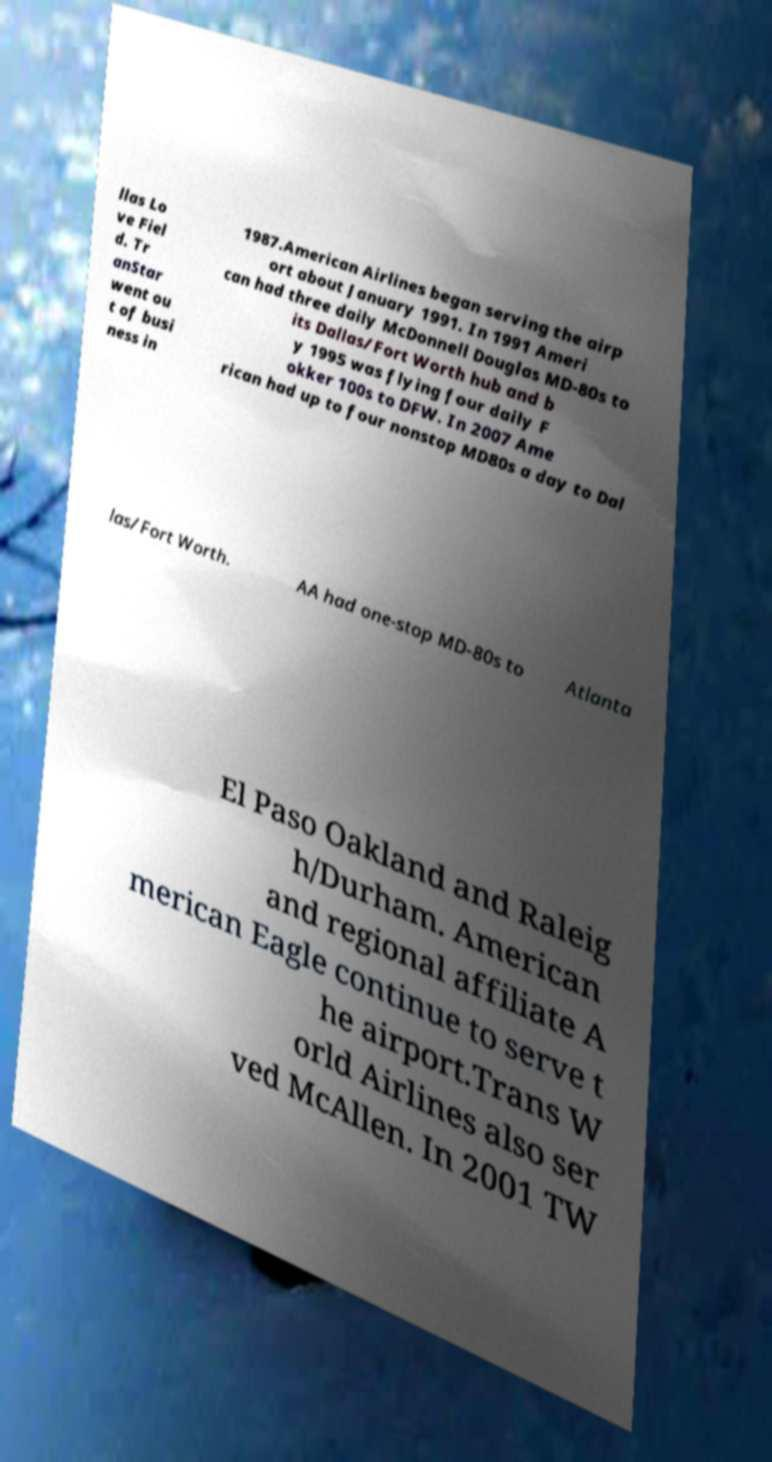There's text embedded in this image that I need extracted. Can you transcribe it verbatim? llas Lo ve Fiel d. Tr anStar went ou t of busi ness in 1987.American Airlines began serving the airp ort about January 1991. In 1991 Ameri can had three daily McDonnell Douglas MD-80s to its Dallas/Fort Worth hub and b y 1995 was flying four daily F okker 100s to DFW. In 2007 Ame rican had up to four nonstop MD80s a day to Dal las/Fort Worth. AA had one-stop MD-80s to Atlanta El Paso Oakland and Raleig h/Durham. American and regional affiliate A merican Eagle continue to serve t he airport.Trans W orld Airlines also ser ved McAllen. In 2001 TW 